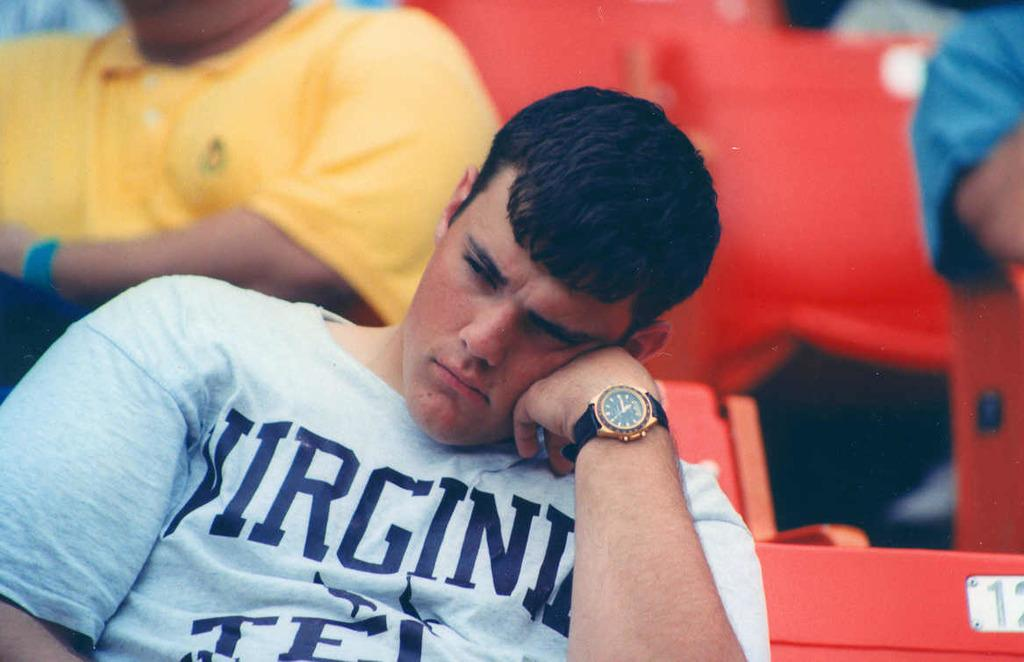<image>
Summarize the visual content of the image. Man sitting with a shirt that says "VIRGINIA". 